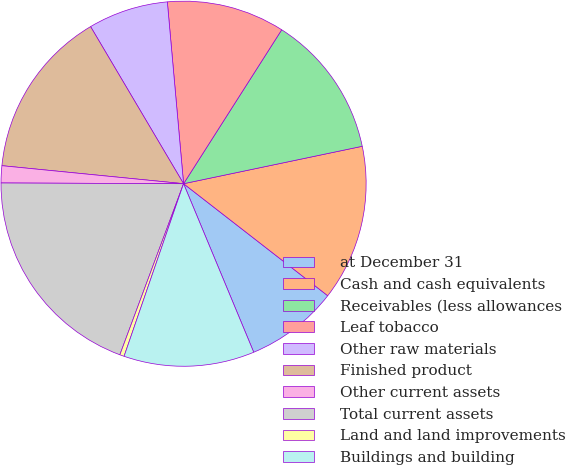Convert chart to OTSL. <chart><loc_0><loc_0><loc_500><loc_500><pie_chart><fcel>at December 31<fcel>Cash and cash equivalents<fcel>Receivables (less allowances<fcel>Leaf tobacco<fcel>Other raw materials<fcel>Finished product<fcel>Other current assets<fcel>Total current assets<fcel>Land and land improvements<fcel>Buildings and building<nl><fcel>8.21%<fcel>13.8%<fcel>12.68%<fcel>10.45%<fcel>7.09%<fcel>14.92%<fcel>1.51%<fcel>19.39%<fcel>0.39%<fcel>11.56%<nl></chart> 